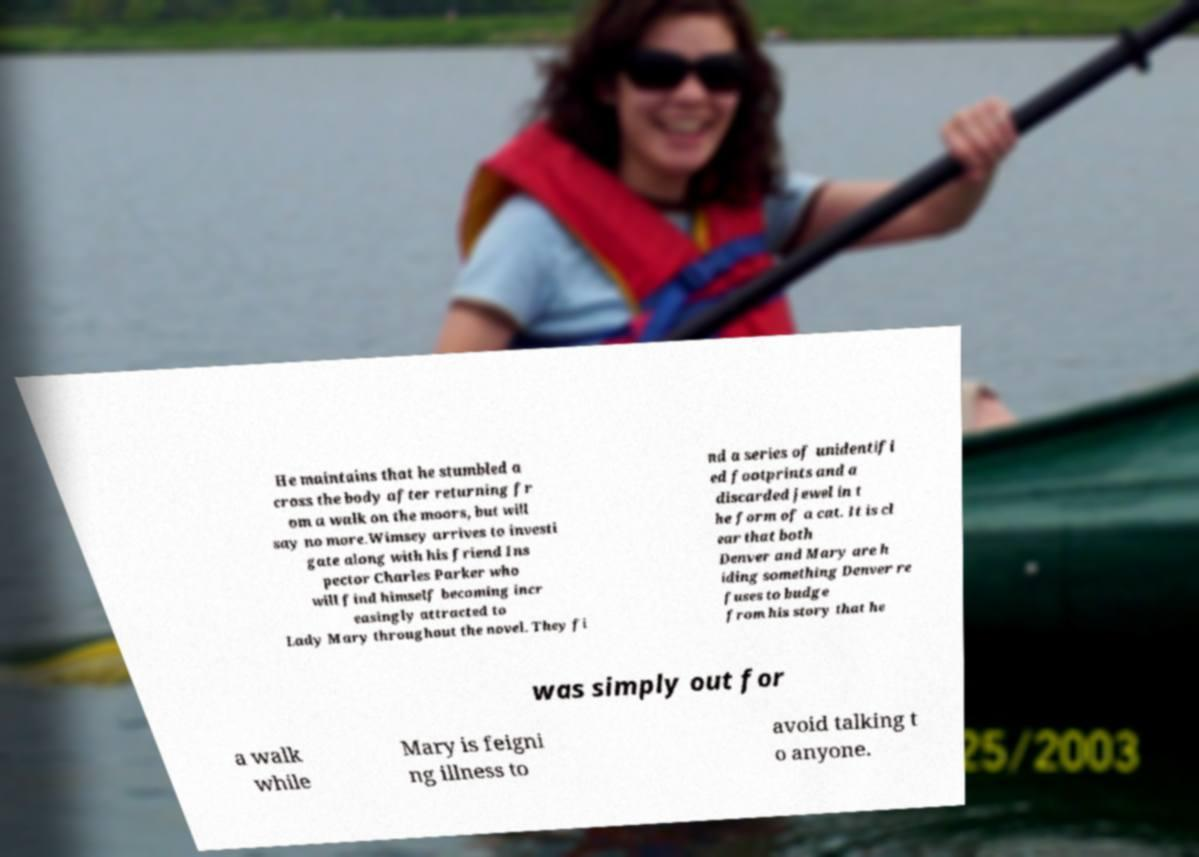Could you extract and type out the text from this image? He maintains that he stumbled a cross the body after returning fr om a walk on the moors, but will say no more.Wimsey arrives to investi gate along with his friend Ins pector Charles Parker who will find himself becoming incr easingly attracted to Lady Mary throughout the novel. They fi nd a series of unidentifi ed footprints and a discarded jewel in t he form of a cat. It is cl ear that both Denver and Mary are h iding something Denver re fuses to budge from his story that he was simply out for a walk while Mary is feigni ng illness to avoid talking t o anyone. 